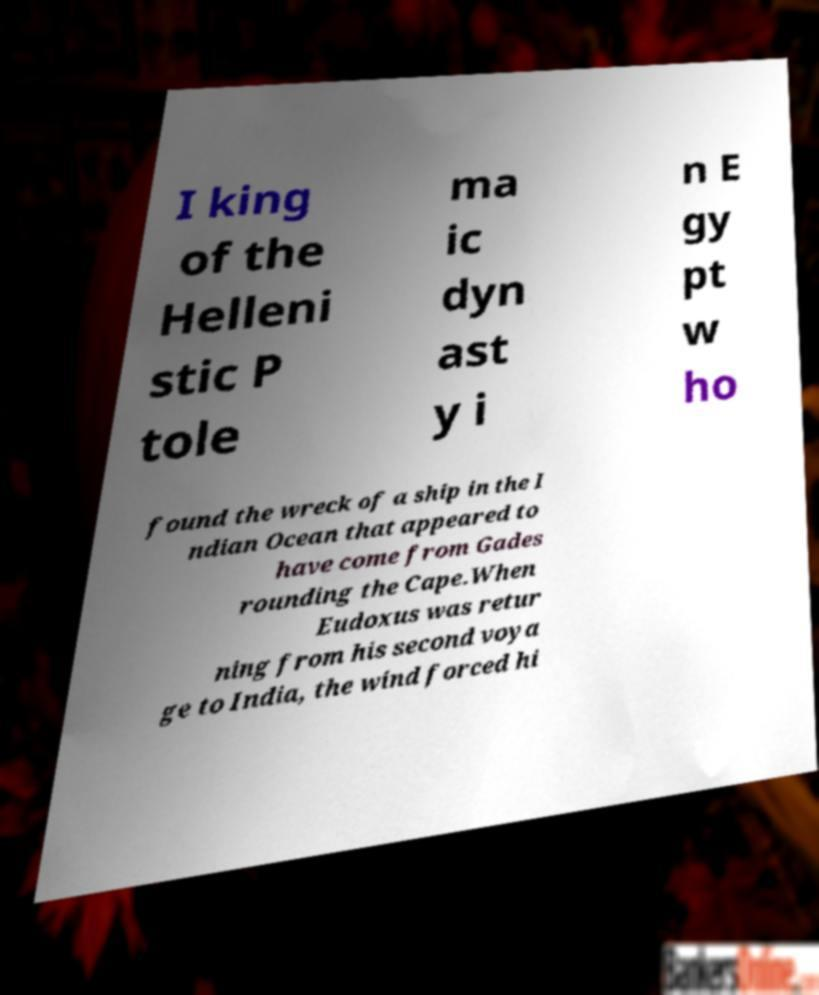Please read and relay the text visible in this image. What does it say? I king of the Helleni stic P tole ma ic dyn ast y i n E gy pt w ho found the wreck of a ship in the I ndian Ocean that appeared to have come from Gades rounding the Cape.When Eudoxus was retur ning from his second voya ge to India, the wind forced hi 